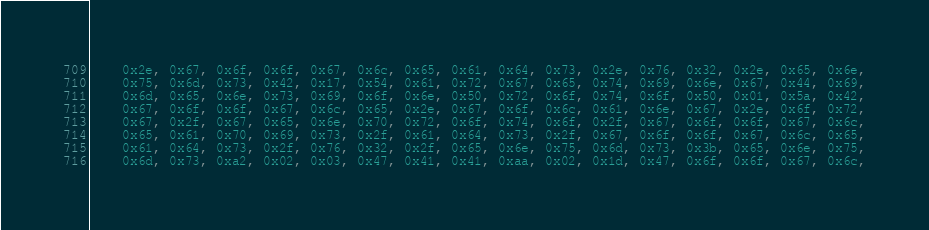Convert code to text. <code><loc_0><loc_0><loc_500><loc_500><_Go_>	0x2e, 0x67, 0x6f, 0x6f, 0x67, 0x6c, 0x65, 0x61, 0x64, 0x73, 0x2e, 0x76, 0x32, 0x2e, 0x65, 0x6e,
	0x75, 0x6d, 0x73, 0x42, 0x17, 0x54, 0x61, 0x72, 0x67, 0x65, 0x74, 0x69, 0x6e, 0x67, 0x44, 0x69,
	0x6d, 0x65, 0x6e, 0x73, 0x69, 0x6f, 0x6e, 0x50, 0x72, 0x6f, 0x74, 0x6f, 0x50, 0x01, 0x5a, 0x42,
	0x67, 0x6f, 0x6f, 0x67, 0x6c, 0x65, 0x2e, 0x67, 0x6f, 0x6c, 0x61, 0x6e, 0x67, 0x2e, 0x6f, 0x72,
	0x67, 0x2f, 0x67, 0x65, 0x6e, 0x70, 0x72, 0x6f, 0x74, 0x6f, 0x2f, 0x67, 0x6f, 0x6f, 0x67, 0x6c,
	0x65, 0x61, 0x70, 0x69, 0x73, 0x2f, 0x61, 0x64, 0x73, 0x2f, 0x67, 0x6f, 0x6f, 0x67, 0x6c, 0x65,
	0x61, 0x64, 0x73, 0x2f, 0x76, 0x32, 0x2f, 0x65, 0x6e, 0x75, 0x6d, 0x73, 0x3b, 0x65, 0x6e, 0x75,
	0x6d, 0x73, 0xa2, 0x02, 0x03, 0x47, 0x41, 0x41, 0xaa, 0x02, 0x1d, 0x47, 0x6f, 0x6f, 0x67, 0x6c,</code> 